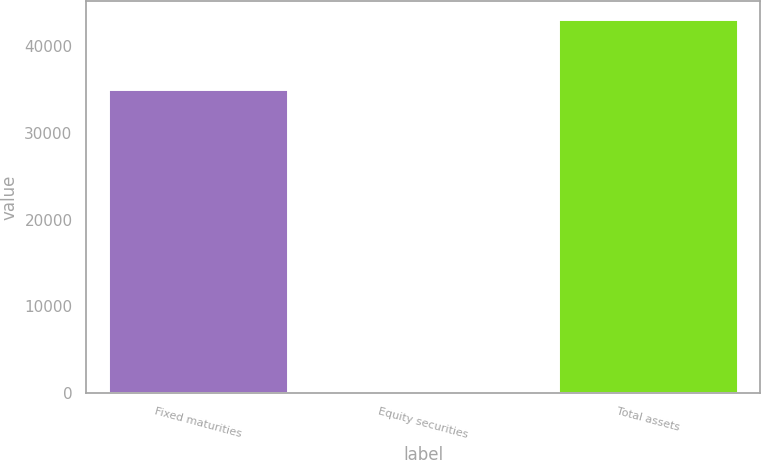<chart> <loc_0><loc_0><loc_500><loc_500><bar_chart><fcel>Fixed maturities<fcel>Equity securities<fcel>Total assets<nl><fcel>35012<fcel>27<fcel>43086<nl></chart> 